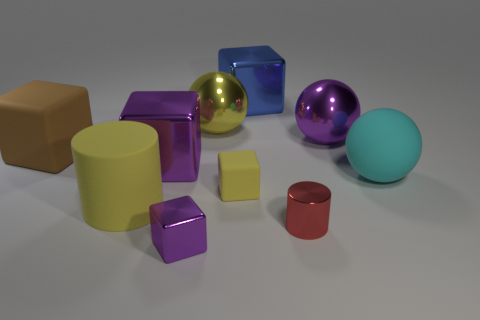What is the shape of the object that is both to the left of the small matte object and behind the purple metallic sphere?
Ensure brevity in your answer.  Sphere. What color is the matte object that is the same shape as the big yellow shiny thing?
Your response must be concise. Cyan. What number of things are metallic things that are in front of the small red metal cylinder or large metal balls that are to the left of the large blue shiny block?
Make the answer very short. 2. There is a red metallic object; what shape is it?
Make the answer very short. Cylinder. What shape is the metallic thing that is the same color as the big rubber cylinder?
Provide a succinct answer. Sphere. How many yellow cylinders have the same material as the brown thing?
Offer a very short reply. 1. What color is the big rubber ball?
Your response must be concise. Cyan. There is a metallic block that is the same size as the red metallic object; what color is it?
Provide a succinct answer. Purple. Is there a matte cube that has the same color as the big cylinder?
Give a very brief answer. Yes. Is the shape of the cyan rubber object behind the red cylinder the same as the purple thing that is on the left side of the tiny purple metallic object?
Your answer should be compact. No. 